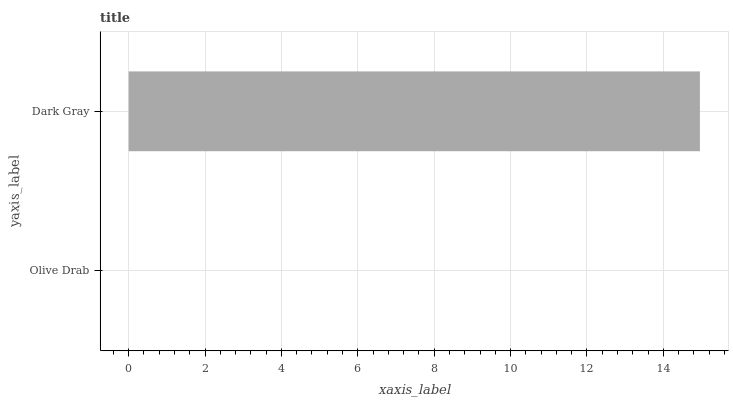Is Olive Drab the minimum?
Answer yes or no. Yes. Is Dark Gray the maximum?
Answer yes or no. Yes. Is Dark Gray the minimum?
Answer yes or no. No. Is Dark Gray greater than Olive Drab?
Answer yes or no. Yes. Is Olive Drab less than Dark Gray?
Answer yes or no. Yes. Is Olive Drab greater than Dark Gray?
Answer yes or no. No. Is Dark Gray less than Olive Drab?
Answer yes or no. No. Is Dark Gray the high median?
Answer yes or no. Yes. Is Olive Drab the low median?
Answer yes or no. Yes. Is Olive Drab the high median?
Answer yes or no. No. Is Dark Gray the low median?
Answer yes or no. No. 